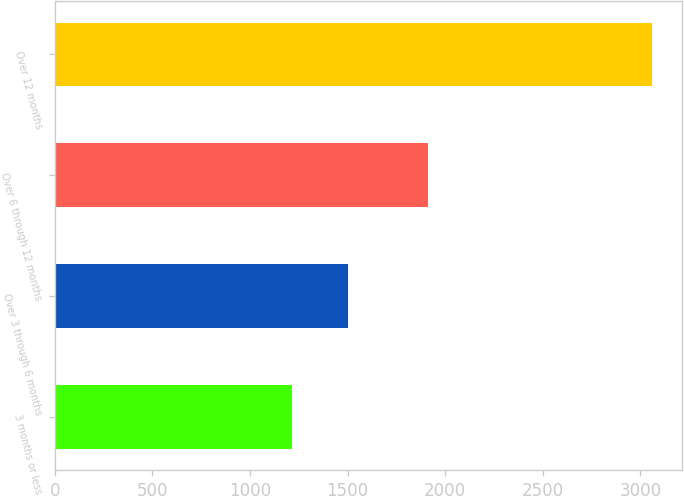Convert chart to OTSL. <chart><loc_0><loc_0><loc_500><loc_500><bar_chart><fcel>3 months or less<fcel>Over 3 through 6 months<fcel>Over 6 through 12 months<fcel>Over 12 months<nl><fcel>1216<fcel>1504<fcel>1910<fcel>3061<nl></chart> 